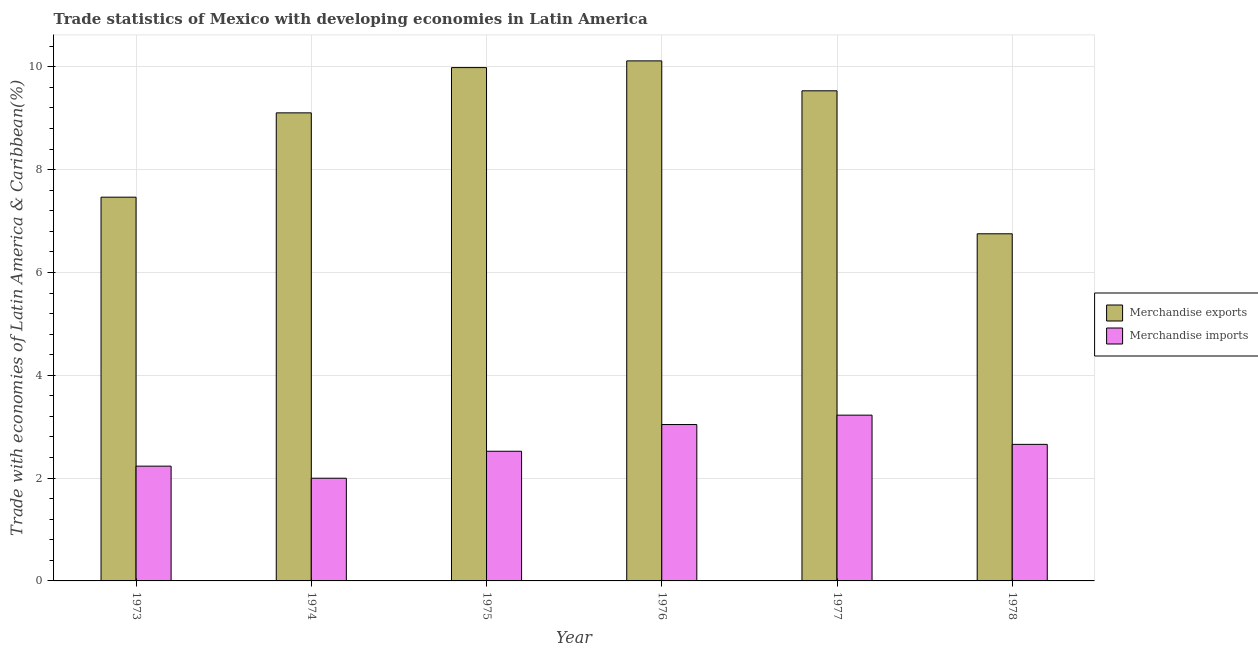How many groups of bars are there?
Make the answer very short. 6. Are the number of bars per tick equal to the number of legend labels?
Keep it short and to the point. Yes. Are the number of bars on each tick of the X-axis equal?
Your response must be concise. Yes. How many bars are there on the 1st tick from the left?
Provide a short and direct response. 2. What is the label of the 4th group of bars from the left?
Make the answer very short. 1976. In how many cases, is the number of bars for a given year not equal to the number of legend labels?
Offer a terse response. 0. What is the merchandise exports in 1978?
Offer a very short reply. 6.75. Across all years, what is the maximum merchandise imports?
Your answer should be compact. 3.22. Across all years, what is the minimum merchandise exports?
Provide a succinct answer. 6.75. In which year was the merchandise imports maximum?
Give a very brief answer. 1977. In which year was the merchandise imports minimum?
Offer a terse response. 1974. What is the total merchandise exports in the graph?
Provide a short and direct response. 52.96. What is the difference between the merchandise imports in 1975 and that in 1976?
Offer a terse response. -0.52. What is the difference between the merchandise exports in 1976 and the merchandise imports in 1975?
Your answer should be compact. 0.13. What is the average merchandise exports per year?
Give a very brief answer. 8.83. In the year 1974, what is the difference between the merchandise exports and merchandise imports?
Make the answer very short. 0. In how many years, is the merchandise exports greater than 10 %?
Your answer should be compact. 1. What is the ratio of the merchandise imports in 1977 to that in 1978?
Provide a succinct answer. 1.21. Is the merchandise imports in 1975 less than that in 1976?
Your response must be concise. Yes. Is the difference between the merchandise exports in 1973 and 1975 greater than the difference between the merchandise imports in 1973 and 1975?
Offer a terse response. No. What is the difference between the highest and the second highest merchandise exports?
Keep it short and to the point. 0.13. What is the difference between the highest and the lowest merchandise exports?
Make the answer very short. 3.36. In how many years, is the merchandise exports greater than the average merchandise exports taken over all years?
Your answer should be very brief. 4. Is the sum of the merchandise exports in 1973 and 1974 greater than the maximum merchandise imports across all years?
Give a very brief answer. Yes. What does the 2nd bar from the left in 1975 represents?
Provide a succinct answer. Merchandise imports. What does the 2nd bar from the right in 1978 represents?
Your response must be concise. Merchandise exports. How many bars are there?
Ensure brevity in your answer.  12. How many years are there in the graph?
Your answer should be compact. 6. Are the values on the major ticks of Y-axis written in scientific E-notation?
Ensure brevity in your answer.  No. Does the graph contain any zero values?
Your answer should be compact. No. How many legend labels are there?
Give a very brief answer. 2. What is the title of the graph?
Give a very brief answer. Trade statistics of Mexico with developing economies in Latin America. Does "Working only" appear as one of the legend labels in the graph?
Your answer should be very brief. No. What is the label or title of the Y-axis?
Keep it short and to the point. Trade with economies of Latin America & Caribbean(%). What is the Trade with economies of Latin America & Caribbean(%) of Merchandise exports in 1973?
Your answer should be very brief. 7.46. What is the Trade with economies of Latin America & Caribbean(%) in Merchandise imports in 1973?
Ensure brevity in your answer.  2.23. What is the Trade with economies of Latin America & Caribbean(%) of Merchandise exports in 1974?
Your answer should be very brief. 9.1. What is the Trade with economies of Latin America & Caribbean(%) in Merchandise imports in 1974?
Offer a very short reply. 2. What is the Trade with economies of Latin America & Caribbean(%) in Merchandise exports in 1975?
Your response must be concise. 9.98. What is the Trade with economies of Latin America & Caribbean(%) of Merchandise imports in 1975?
Your answer should be very brief. 2.52. What is the Trade with economies of Latin America & Caribbean(%) in Merchandise exports in 1976?
Ensure brevity in your answer.  10.12. What is the Trade with economies of Latin America & Caribbean(%) in Merchandise imports in 1976?
Your answer should be very brief. 3.04. What is the Trade with economies of Latin America & Caribbean(%) of Merchandise exports in 1977?
Provide a short and direct response. 9.53. What is the Trade with economies of Latin America & Caribbean(%) of Merchandise imports in 1977?
Your answer should be very brief. 3.22. What is the Trade with economies of Latin America & Caribbean(%) of Merchandise exports in 1978?
Make the answer very short. 6.75. What is the Trade with economies of Latin America & Caribbean(%) of Merchandise imports in 1978?
Provide a short and direct response. 2.66. Across all years, what is the maximum Trade with economies of Latin America & Caribbean(%) in Merchandise exports?
Give a very brief answer. 10.12. Across all years, what is the maximum Trade with economies of Latin America & Caribbean(%) in Merchandise imports?
Your response must be concise. 3.22. Across all years, what is the minimum Trade with economies of Latin America & Caribbean(%) of Merchandise exports?
Offer a terse response. 6.75. Across all years, what is the minimum Trade with economies of Latin America & Caribbean(%) of Merchandise imports?
Provide a succinct answer. 2. What is the total Trade with economies of Latin America & Caribbean(%) of Merchandise exports in the graph?
Provide a succinct answer. 52.95. What is the total Trade with economies of Latin America & Caribbean(%) in Merchandise imports in the graph?
Give a very brief answer. 15.68. What is the difference between the Trade with economies of Latin America & Caribbean(%) of Merchandise exports in 1973 and that in 1974?
Your answer should be compact. -1.64. What is the difference between the Trade with economies of Latin America & Caribbean(%) in Merchandise imports in 1973 and that in 1974?
Your answer should be compact. 0.23. What is the difference between the Trade with economies of Latin America & Caribbean(%) in Merchandise exports in 1973 and that in 1975?
Offer a terse response. -2.52. What is the difference between the Trade with economies of Latin America & Caribbean(%) in Merchandise imports in 1973 and that in 1975?
Make the answer very short. -0.29. What is the difference between the Trade with economies of Latin America & Caribbean(%) of Merchandise exports in 1973 and that in 1976?
Your answer should be compact. -2.65. What is the difference between the Trade with economies of Latin America & Caribbean(%) of Merchandise imports in 1973 and that in 1976?
Your response must be concise. -0.81. What is the difference between the Trade with economies of Latin America & Caribbean(%) in Merchandise exports in 1973 and that in 1977?
Offer a terse response. -2.07. What is the difference between the Trade with economies of Latin America & Caribbean(%) in Merchandise imports in 1973 and that in 1977?
Provide a short and direct response. -0.99. What is the difference between the Trade with economies of Latin America & Caribbean(%) in Merchandise exports in 1973 and that in 1978?
Make the answer very short. 0.71. What is the difference between the Trade with economies of Latin America & Caribbean(%) in Merchandise imports in 1973 and that in 1978?
Ensure brevity in your answer.  -0.42. What is the difference between the Trade with economies of Latin America & Caribbean(%) of Merchandise exports in 1974 and that in 1975?
Ensure brevity in your answer.  -0.88. What is the difference between the Trade with economies of Latin America & Caribbean(%) in Merchandise imports in 1974 and that in 1975?
Keep it short and to the point. -0.52. What is the difference between the Trade with economies of Latin America & Caribbean(%) in Merchandise exports in 1974 and that in 1976?
Make the answer very short. -1.01. What is the difference between the Trade with economies of Latin America & Caribbean(%) in Merchandise imports in 1974 and that in 1976?
Provide a short and direct response. -1.04. What is the difference between the Trade with economies of Latin America & Caribbean(%) in Merchandise exports in 1974 and that in 1977?
Your answer should be very brief. -0.43. What is the difference between the Trade with economies of Latin America & Caribbean(%) of Merchandise imports in 1974 and that in 1977?
Give a very brief answer. -1.23. What is the difference between the Trade with economies of Latin America & Caribbean(%) in Merchandise exports in 1974 and that in 1978?
Your answer should be very brief. 2.35. What is the difference between the Trade with economies of Latin America & Caribbean(%) in Merchandise imports in 1974 and that in 1978?
Give a very brief answer. -0.66. What is the difference between the Trade with economies of Latin America & Caribbean(%) in Merchandise exports in 1975 and that in 1976?
Provide a succinct answer. -0.13. What is the difference between the Trade with economies of Latin America & Caribbean(%) in Merchandise imports in 1975 and that in 1976?
Provide a short and direct response. -0.52. What is the difference between the Trade with economies of Latin America & Caribbean(%) of Merchandise exports in 1975 and that in 1977?
Offer a very short reply. 0.45. What is the difference between the Trade with economies of Latin America & Caribbean(%) of Merchandise imports in 1975 and that in 1977?
Provide a succinct answer. -0.7. What is the difference between the Trade with economies of Latin America & Caribbean(%) of Merchandise exports in 1975 and that in 1978?
Your answer should be compact. 3.23. What is the difference between the Trade with economies of Latin America & Caribbean(%) in Merchandise imports in 1975 and that in 1978?
Give a very brief answer. -0.13. What is the difference between the Trade with economies of Latin America & Caribbean(%) of Merchandise exports in 1976 and that in 1977?
Provide a short and direct response. 0.58. What is the difference between the Trade with economies of Latin America & Caribbean(%) in Merchandise imports in 1976 and that in 1977?
Keep it short and to the point. -0.18. What is the difference between the Trade with economies of Latin America & Caribbean(%) of Merchandise exports in 1976 and that in 1978?
Give a very brief answer. 3.36. What is the difference between the Trade with economies of Latin America & Caribbean(%) of Merchandise imports in 1976 and that in 1978?
Provide a succinct answer. 0.39. What is the difference between the Trade with economies of Latin America & Caribbean(%) in Merchandise exports in 1977 and that in 1978?
Ensure brevity in your answer.  2.78. What is the difference between the Trade with economies of Latin America & Caribbean(%) of Merchandise imports in 1977 and that in 1978?
Keep it short and to the point. 0.57. What is the difference between the Trade with economies of Latin America & Caribbean(%) of Merchandise exports in 1973 and the Trade with economies of Latin America & Caribbean(%) of Merchandise imports in 1974?
Your answer should be very brief. 5.47. What is the difference between the Trade with economies of Latin America & Caribbean(%) in Merchandise exports in 1973 and the Trade with economies of Latin America & Caribbean(%) in Merchandise imports in 1975?
Give a very brief answer. 4.94. What is the difference between the Trade with economies of Latin America & Caribbean(%) in Merchandise exports in 1973 and the Trade with economies of Latin America & Caribbean(%) in Merchandise imports in 1976?
Ensure brevity in your answer.  4.42. What is the difference between the Trade with economies of Latin America & Caribbean(%) of Merchandise exports in 1973 and the Trade with economies of Latin America & Caribbean(%) of Merchandise imports in 1977?
Offer a terse response. 4.24. What is the difference between the Trade with economies of Latin America & Caribbean(%) in Merchandise exports in 1973 and the Trade with economies of Latin America & Caribbean(%) in Merchandise imports in 1978?
Provide a short and direct response. 4.81. What is the difference between the Trade with economies of Latin America & Caribbean(%) of Merchandise exports in 1974 and the Trade with economies of Latin America & Caribbean(%) of Merchandise imports in 1975?
Provide a short and direct response. 6.58. What is the difference between the Trade with economies of Latin America & Caribbean(%) in Merchandise exports in 1974 and the Trade with economies of Latin America & Caribbean(%) in Merchandise imports in 1976?
Provide a succinct answer. 6.06. What is the difference between the Trade with economies of Latin America & Caribbean(%) in Merchandise exports in 1974 and the Trade with economies of Latin America & Caribbean(%) in Merchandise imports in 1977?
Keep it short and to the point. 5.88. What is the difference between the Trade with economies of Latin America & Caribbean(%) of Merchandise exports in 1974 and the Trade with economies of Latin America & Caribbean(%) of Merchandise imports in 1978?
Give a very brief answer. 6.45. What is the difference between the Trade with economies of Latin America & Caribbean(%) of Merchandise exports in 1975 and the Trade with economies of Latin America & Caribbean(%) of Merchandise imports in 1976?
Your answer should be compact. 6.94. What is the difference between the Trade with economies of Latin America & Caribbean(%) in Merchandise exports in 1975 and the Trade with economies of Latin America & Caribbean(%) in Merchandise imports in 1977?
Give a very brief answer. 6.76. What is the difference between the Trade with economies of Latin America & Caribbean(%) in Merchandise exports in 1975 and the Trade with economies of Latin America & Caribbean(%) in Merchandise imports in 1978?
Give a very brief answer. 7.33. What is the difference between the Trade with economies of Latin America & Caribbean(%) of Merchandise exports in 1976 and the Trade with economies of Latin America & Caribbean(%) of Merchandise imports in 1977?
Offer a terse response. 6.89. What is the difference between the Trade with economies of Latin America & Caribbean(%) in Merchandise exports in 1976 and the Trade with economies of Latin America & Caribbean(%) in Merchandise imports in 1978?
Your response must be concise. 7.46. What is the difference between the Trade with economies of Latin America & Caribbean(%) in Merchandise exports in 1977 and the Trade with economies of Latin America & Caribbean(%) in Merchandise imports in 1978?
Give a very brief answer. 6.88. What is the average Trade with economies of Latin America & Caribbean(%) of Merchandise exports per year?
Your response must be concise. 8.83. What is the average Trade with economies of Latin America & Caribbean(%) in Merchandise imports per year?
Your answer should be very brief. 2.61. In the year 1973, what is the difference between the Trade with economies of Latin America & Caribbean(%) in Merchandise exports and Trade with economies of Latin America & Caribbean(%) in Merchandise imports?
Keep it short and to the point. 5.23. In the year 1974, what is the difference between the Trade with economies of Latin America & Caribbean(%) of Merchandise exports and Trade with economies of Latin America & Caribbean(%) of Merchandise imports?
Your response must be concise. 7.11. In the year 1975, what is the difference between the Trade with economies of Latin America & Caribbean(%) in Merchandise exports and Trade with economies of Latin America & Caribbean(%) in Merchandise imports?
Your answer should be compact. 7.46. In the year 1976, what is the difference between the Trade with economies of Latin America & Caribbean(%) in Merchandise exports and Trade with economies of Latin America & Caribbean(%) in Merchandise imports?
Make the answer very short. 7.07. In the year 1977, what is the difference between the Trade with economies of Latin America & Caribbean(%) of Merchandise exports and Trade with economies of Latin America & Caribbean(%) of Merchandise imports?
Give a very brief answer. 6.31. In the year 1978, what is the difference between the Trade with economies of Latin America & Caribbean(%) of Merchandise exports and Trade with economies of Latin America & Caribbean(%) of Merchandise imports?
Give a very brief answer. 4.1. What is the ratio of the Trade with economies of Latin America & Caribbean(%) of Merchandise exports in 1973 to that in 1974?
Provide a succinct answer. 0.82. What is the ratio of the Trade with economies of Latin America & Caribbean(%) of Merchandise imports in 1973 to that in 1974?
Offer a very short reply. 1.12. What is the ratio of the Trade with economies of Latin America & Caribbean(%) of Merchandise exports in 1973 to that in 1975?
Your answer should be compact. 0.75. What is the ratio of the Trade with economies of Latin America & Caribbean(%) in Merchandise imports in 1973 to that in 1975?
Your answer should be very brief. 0.89. What is the ratio of the Trade with economies of Latin America & Caribbean(%) in Merchandise exports in 1973 to that in 1976?
Offer a very short reply. 0.74. What is the ratio of the Trade with economies of Latin America & Caribbean(%) in Merchandise imports in 1973 to that in 1976?
Make the answer very short. 0.73. What is the ratio of the Trade with economies of Latin America & Caribbean(%) of Merchandise exports in 1973 to that in 1977?
Offer a very short reply. 0.78. What is the ratio of the Trade with economies of Latin America & Caribbean(%) of Merchandise imports in 1973 to that in 1977?
Make the answer very short. 0.69. What is the ratio of the Trade with economies of Latin America & Caribbean(%) of Merchandise exports in 1973 to that in 1978?
Your answer should be very brief. 1.11. What is the ratio of the Trade with economies of Latin America & Caribbean(%) of Merchandise imports in 1973 to that in 1978?
Keep it short and to the point. 0.84. What is the ratio of the Trade with economies of Latin America & Caribbean(%) of Merchandise exports in 1974 to that in 1975?
Your answer should be compact. 0.91. What is the ratio of the Trade with economies of Latin America & Caribbean(%) of Merchandise imports in 1974 to that in 1975?
Your response must be concise. 0.79. What is the ratio of the Trade with economies of Latin America & Caribbean(%) in Merchandise exports in 1974 to that in 1976?
Ensure brevity in your answer.  0.9. What is the ratio of the Trade with economies of Latin America & Caribbean(%) in Merchandise imports in 1974 to that in 1976?
Provide a short and direct response. 0.66. What is the ratio of the Trade with economies of Latin America & Caribbean(%) of Merchandise exports in 1974 to that in 1977?
Your answer should be very brief. 0.95. What is the ratio of the Trade with economies of Latin America & Caribbean(%) in Merchandise imports in 1974 to that in 1977?
Provide a succinct answer. 0.62. What is the ratio of the Trade with economies of Latin America & Caribbean(%) of Merchandise exports in 1974 to that in 1978?
Your answer should be compact. 1.35. What is the ratio of the Trade with economies of Latin America & Caribbean(%) of Merchandise imports in 1974 to that in 1978?
Your answer should be very brief. 0.75. What is the ratio of the Trade with economies of Latin America & Caribbean(%) of Merchandise exports in 1975 to that in 1976?
Give a very brief answer. 0.99. What is the ratio of the Trade with economies of Latin America & Caribbean(%) in Merchandise imports in 1975 to that in 1976?
Keep it short and to the point. 0.83. What is the ratio of the Trade with economies of Latin America & Caribbean(%) of Merchandise exports in 1975 to that in 1977?
Offer a very short reply. 1.05. What is the ratio of the Trade with economies of Latin America & Caribbean(%) in Merchandise imports in 1975 to that in 1977?
Offer a terse response. 0.78. What is the ratio of the Trade with economies of Latin America & Caribbean(%) in Merchandise exports in 1975 to that in 1978?
Your answer should be very brief. 1.48. What is the ratio of the Trade with economies of Latin America & Caribbean(%) in Merchandise imports in 1975 to that in 1978?
Your answer should be very brief. 0.95. What is the ratio of the Trade with economies of Latin America & Caribbean(%) of Merchandise exports in 1976 to that in 1977?
Make the answer very short. 1.06. What is the ratio of the Trade with economies of Latin America & Caribbean(%) of Merchandise imports in 1976 to that in 1977?
Ensure brevity in your answer.  0.94. What is the ratio of the Trade with economies of Latin America & Caribbean(%) of Merchandise exports in 1976 to that in 1978?
Offer a very short reply. 1.5. What is the ratio of the Trade with economies of Latin America & Caribbean(%) in Merchandise imports in 1976 to that in 1978?
Offer a very short reply. 1.15. What is the ratio of the Trade with economies of Latin America & Caribbean(%) in Merchandise exports in 1977 to that in 1978?
Give a very brief answer. 1.41. What is the ratio of the Trade with economies of Latin America & Caribbean(%) in Merchandise imports in 1977 to that in 1978?
Your response must be concise. 1.21. What is the difference between the highest and the second highest Trade with economies of Latin America & Caribbean(%) in Merchandise exports?
Make the answer very short. 0.13. What is the difference between the highest and the second highest Trade with economies of Latin America & Caribbean(%) in Merchandise imports?
Your response must be concise. 0.18. What is the difference between the highest and the lowest Trade with economies of Latin America & Caribbean(%) in Merchandise exports?
Your response must be concise. 3.36. What is the difference between the highest and the lowest Trade with economies of Latin America & Caribbean(%) in Merchandise imports?
Keep it short and to the point. 1.23. 